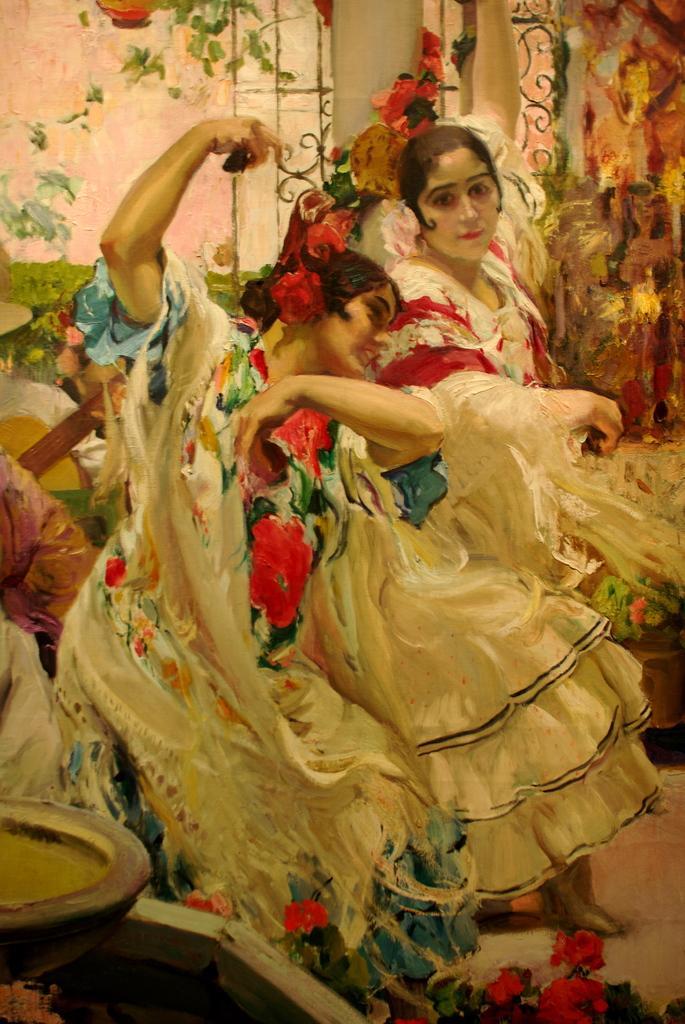Describe this image in one or two sentences. In this picture we can see a painting, in the painting we can find two women. 